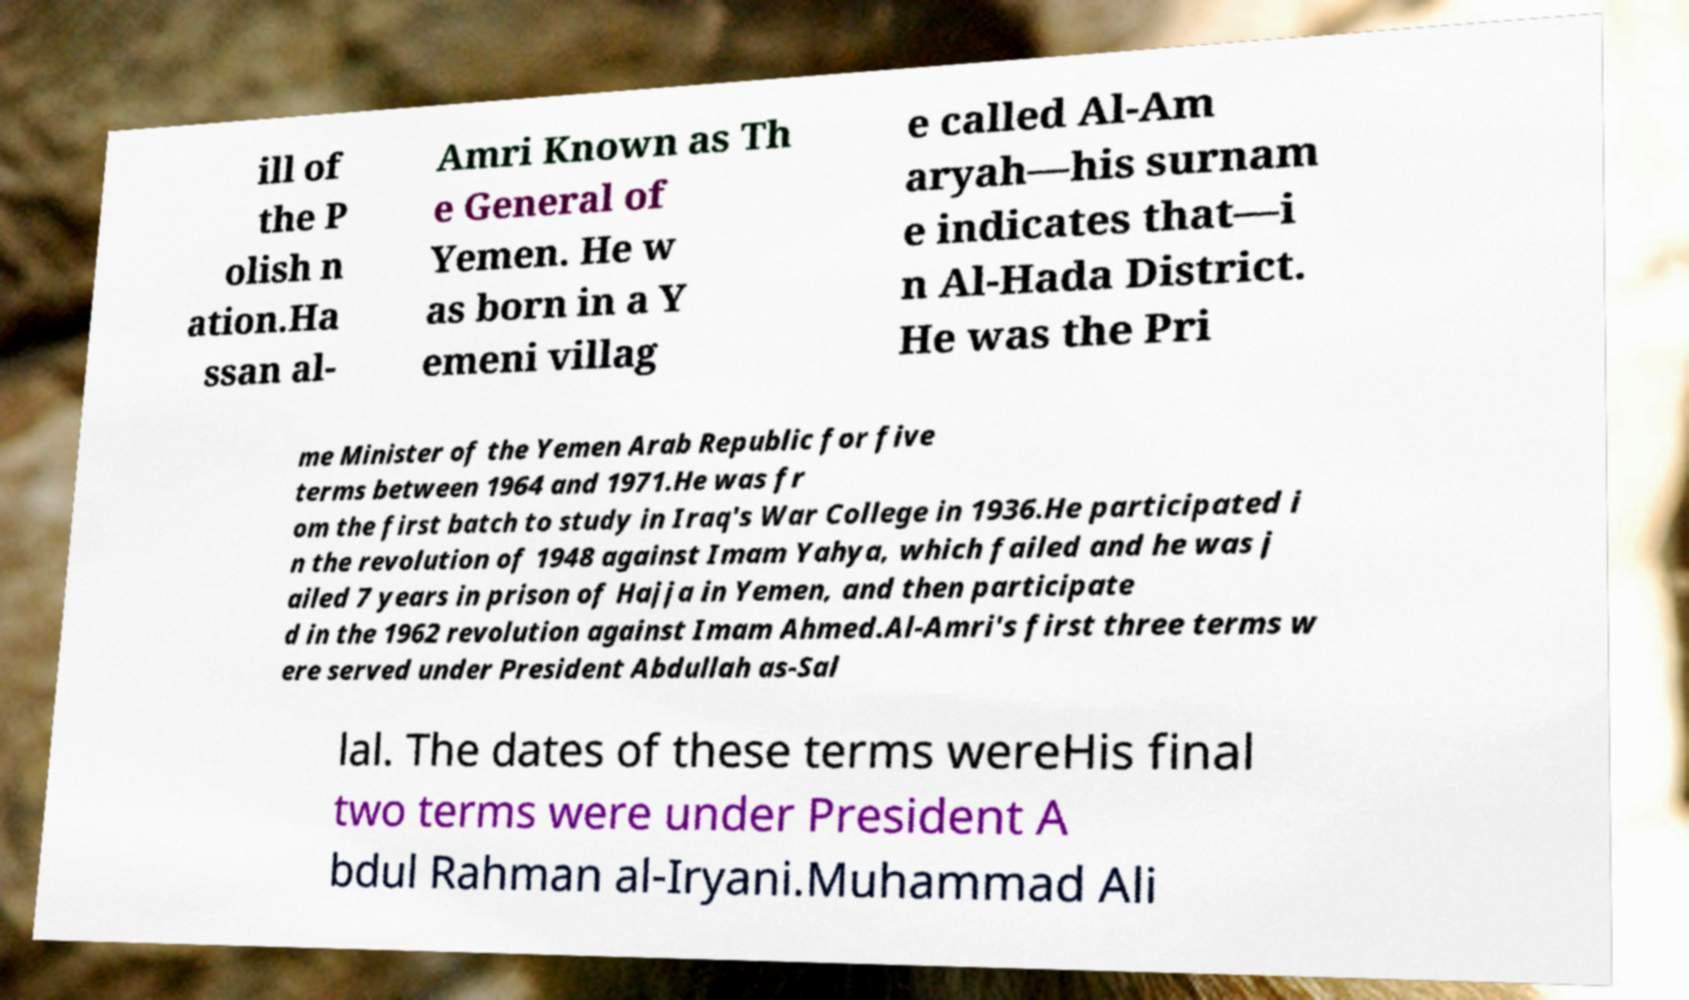Can you accurately transcribe the text from the provided image for me? ill of the P olish n ation.Ha ssan al- Amri Known as Th e General of Yemen. He w as born in a Y emeni villag e called Al-Am aryah—his surnam e indicates that—i n Al-Hada District. He was the Pri me Minister of the Yemen Arab Republic for five terms between 1964 and 1971.He was fr om the first batch to study in Iraq's War College in 1936.He participated i n the revolution of 1948 against Imam Yahya, which failed and he was j ailed 7 years in prison of Hajja in Yemen, and then participate d in the 1962 revolution against Imam Ahmed.Al-Amri's first three terms w ere served under President Abdullah as-Sal lal. The dates of these terms wereHis final two terms were under President A bdul Rahman al-Iryani.Muhammad Ali 